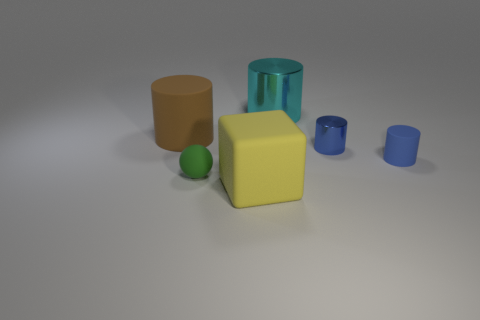Add 3 small blue matte things. How many objects exist? 9 Subtract all spheres. How many objects are left? 5 Subtract all small red metallic cubes. Subtract all yellow rubber blocks. How many objects are left? 5 Add 3 small blue cylinders. How many small blue cylinders are left? 5 Add 1 large cyan cylinders. How many large cyan cylinders exist? 2 Subtract 0 brown blocks. How many objects are left? 6 